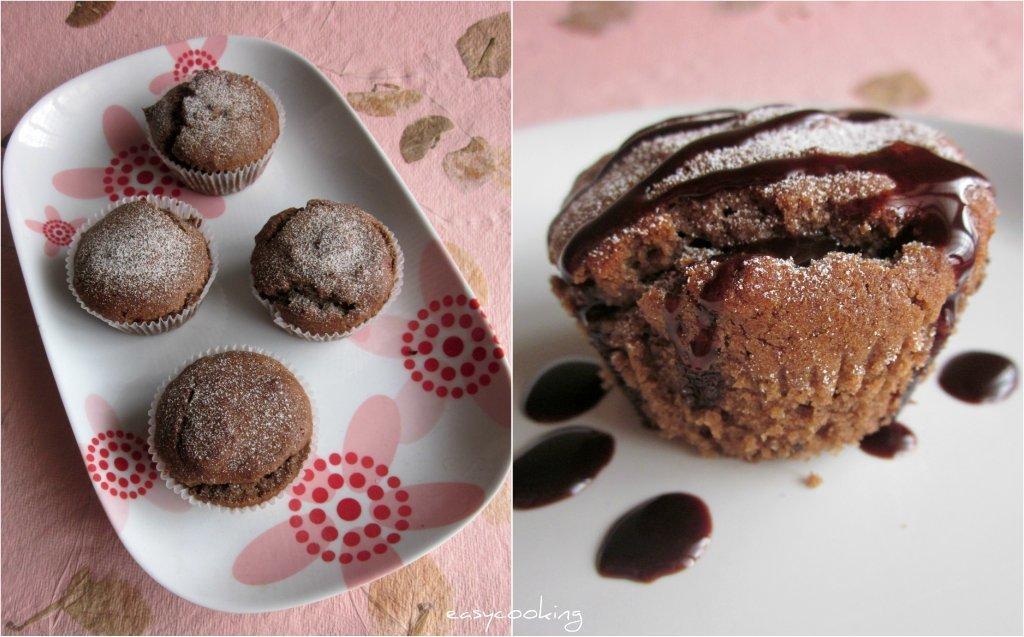Describe this image in one or two sentences. On the left side of the image we can see four cupcakes in a tray. On the right side of the image we can see a cupcake and some chocolate drops in a tray. 